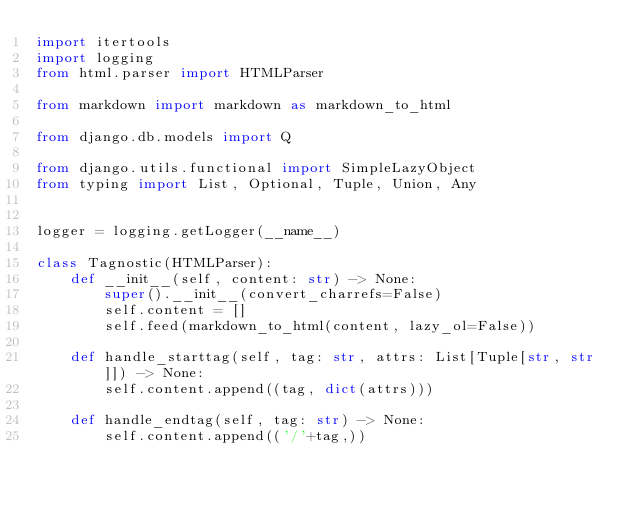Convert code to text. <code><loc_0><loc_0><loc_500><loc_500><_Python_>import itertools
import logging
from html.parser import HTMLParser

from markdown import markdown as markdown_to_html

from django.db.models import Q

from django.utils.functional import SimpleLazyObject
from typing import List, Optional, Tuple, Union, Any


logger = logging.getLogger(__name__)

class Tagnostic(HTMLParser):
    def __init__(self, content: str) -> None:
        super().__init__(convert_charrefs=False)
        self.content = []
        self.feed(markdown_to_html(content, lazy_ol=False))

    def handle_starttag(self, tag: str, attrs: List[Tuple[str, str]]) -> None:
        self.content.append((tag, dict(attrs)))

    def handle_endtag(self, tag: str) -> None:
        self.content.append(('/'+tag,))
</code> 